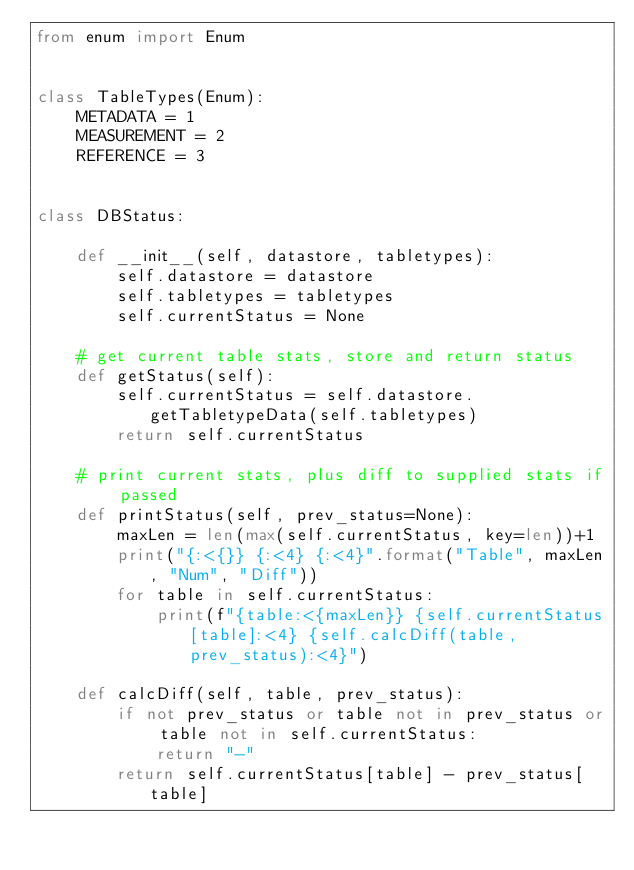Convert code to text. <code><loc_0><loc_0><loc_500><loc_500><_Python_>from enum import Enum


class TableTypes(Enum):
    METADATA = 1
    MEASUREMENT = 2
    REFERENCE = 3


class DBStatus:

    def __init__(self, datastore, tabletypes):
        self.datastore = datastore
        self.tabletypes = tabletypes
        self.currentStatus = None

    # get current table stats, store and return status
    def getStatus(self):
        self.currentStatus = self.datastore.getTabletypeData(self.tabletypes)
        return self.currentStatus

    # print current stats, plus diff to supplied stats if passed
    def printStatus(self, prev_status=None):
        maxLen = len(max(self.currentStatus, key=len))+1
        print("{:<{}} {:<4} {:<4}".format("Table", maxLen, "Num", "Diff"))
        for table in self.currentStatus:
            print(f"{table:<{maxLen}} {self.currentStatus[table]:<4} {self.calcDiff(table, prev_status):<4}")

    def calcDiff(self, table, prev_status):
        if not prev_status or table not in prev_status or table not in self.currentStatus:
            return "-"
        return self.currentStatus[table] - prev_status[table]</code> 